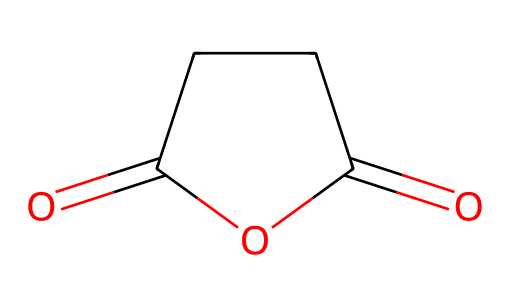What is the name of the chemical represented by the SMILES? The SMILES notation corresponds to succinic anhydride, which can be identified by recognizing the cyclic structure formed by the carbonyl groups and the maintained carbon atoms.
Answer: succinic anhydride How many carbon atoms are present in succinic anhydride? The SMILES indicates a total of four carbon atoms (C) directly visible in the structure: two from each of the carboxyl groups and the two in between.
Answer: four What type of functional groups are present in succinic anhydride? By analyzing the structure, we see that succinic anhydride contains two carbonyl (C=O) groups and an anhydride functional group, which is evident from the cyclic arrangement of the carbon and oxygen atoms.
Answer: anhydride What is the total number of oxygen atoms in succinic anhydride? By counting the oxygen atoms in the structure, there are two carbonyl oxygens (C=O) and one oxygen in the anhydride linkage, totaling three oxygen atoms.
Answer: three How does the presence of the anhydride group affect the reactivity of succinic anhydride? The anhydride group makes succinic anhydride more reactive than its corresponding carboxylic acids due to the tendency of anhydrides to undergo nucleophilic attack, facilitated by the presence of the carbonyl groups.
Answer: increases reactivity Which element is primarily responsible for the acid properties of succinic anhydride? The carbonyl oxygen atoms contribute to the acidic characteristics of succinic anhydride by being able to stabilize negative charge when the molecule reacts, especially in hydration or with nucleophiles.
Answer: oxygen 